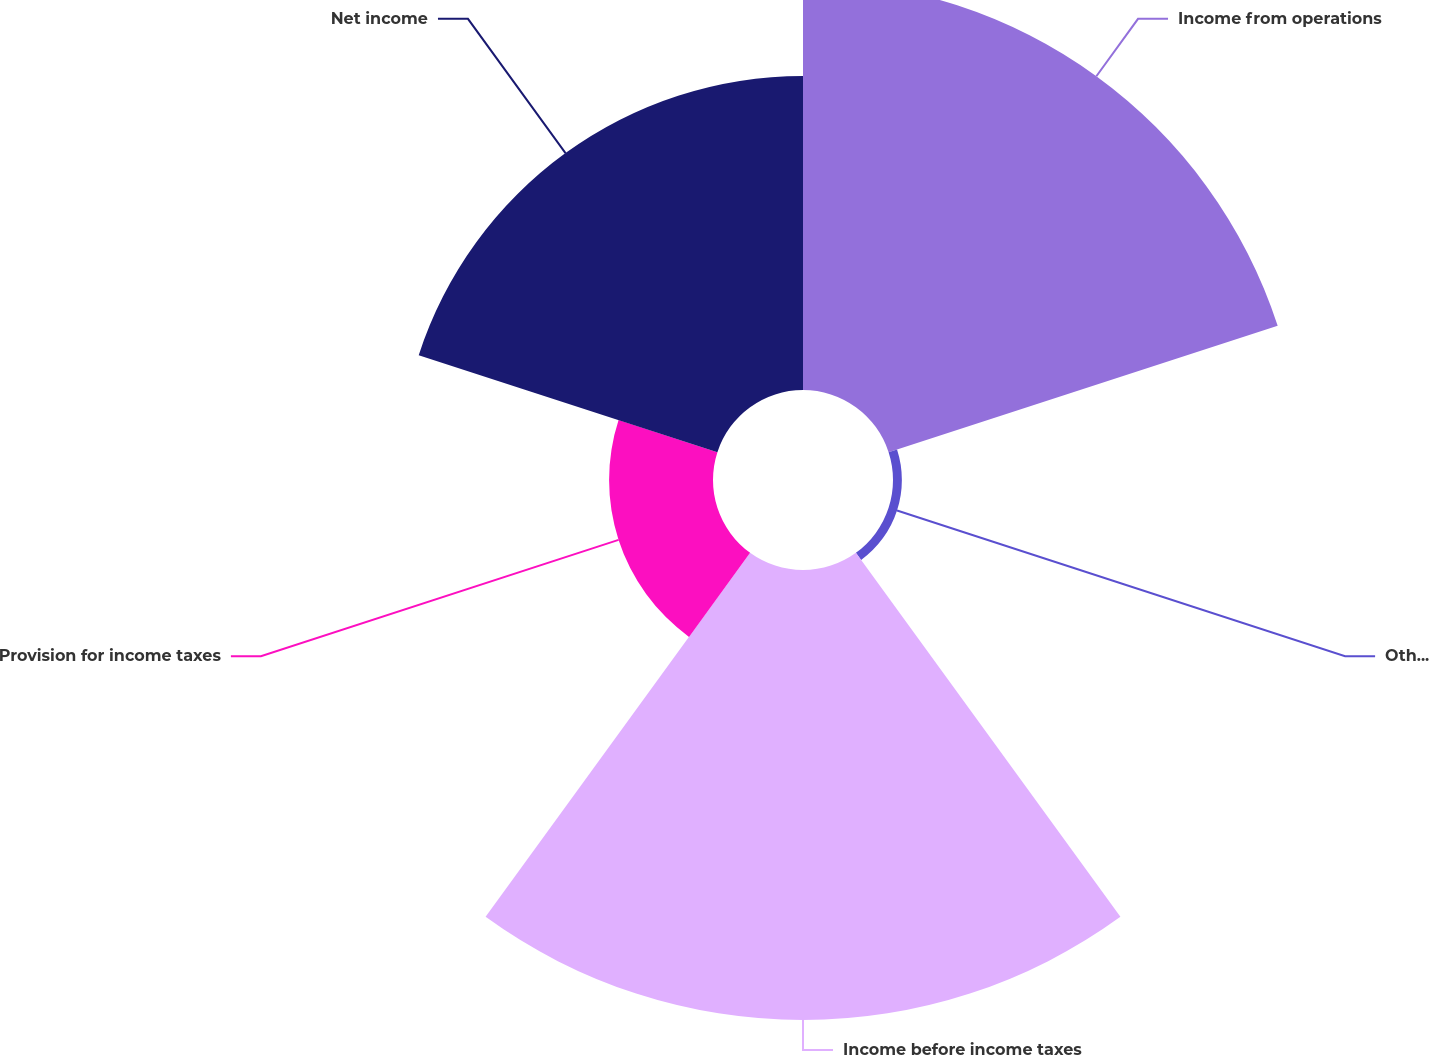Convert chart to OTSL. <chart><loc_0><loc_0><loc_500><loc_500><pie_chart><fcel>Income from operations<fcel>Other income net<fcel>Income before income taxes<fcel>Provision for income taxes<fcel>Net income<nl><fcel>31.81%<fcel>0.69%<fcel>34.99%<fcel>8.08%<fcel>24.42%<nl></chart> 